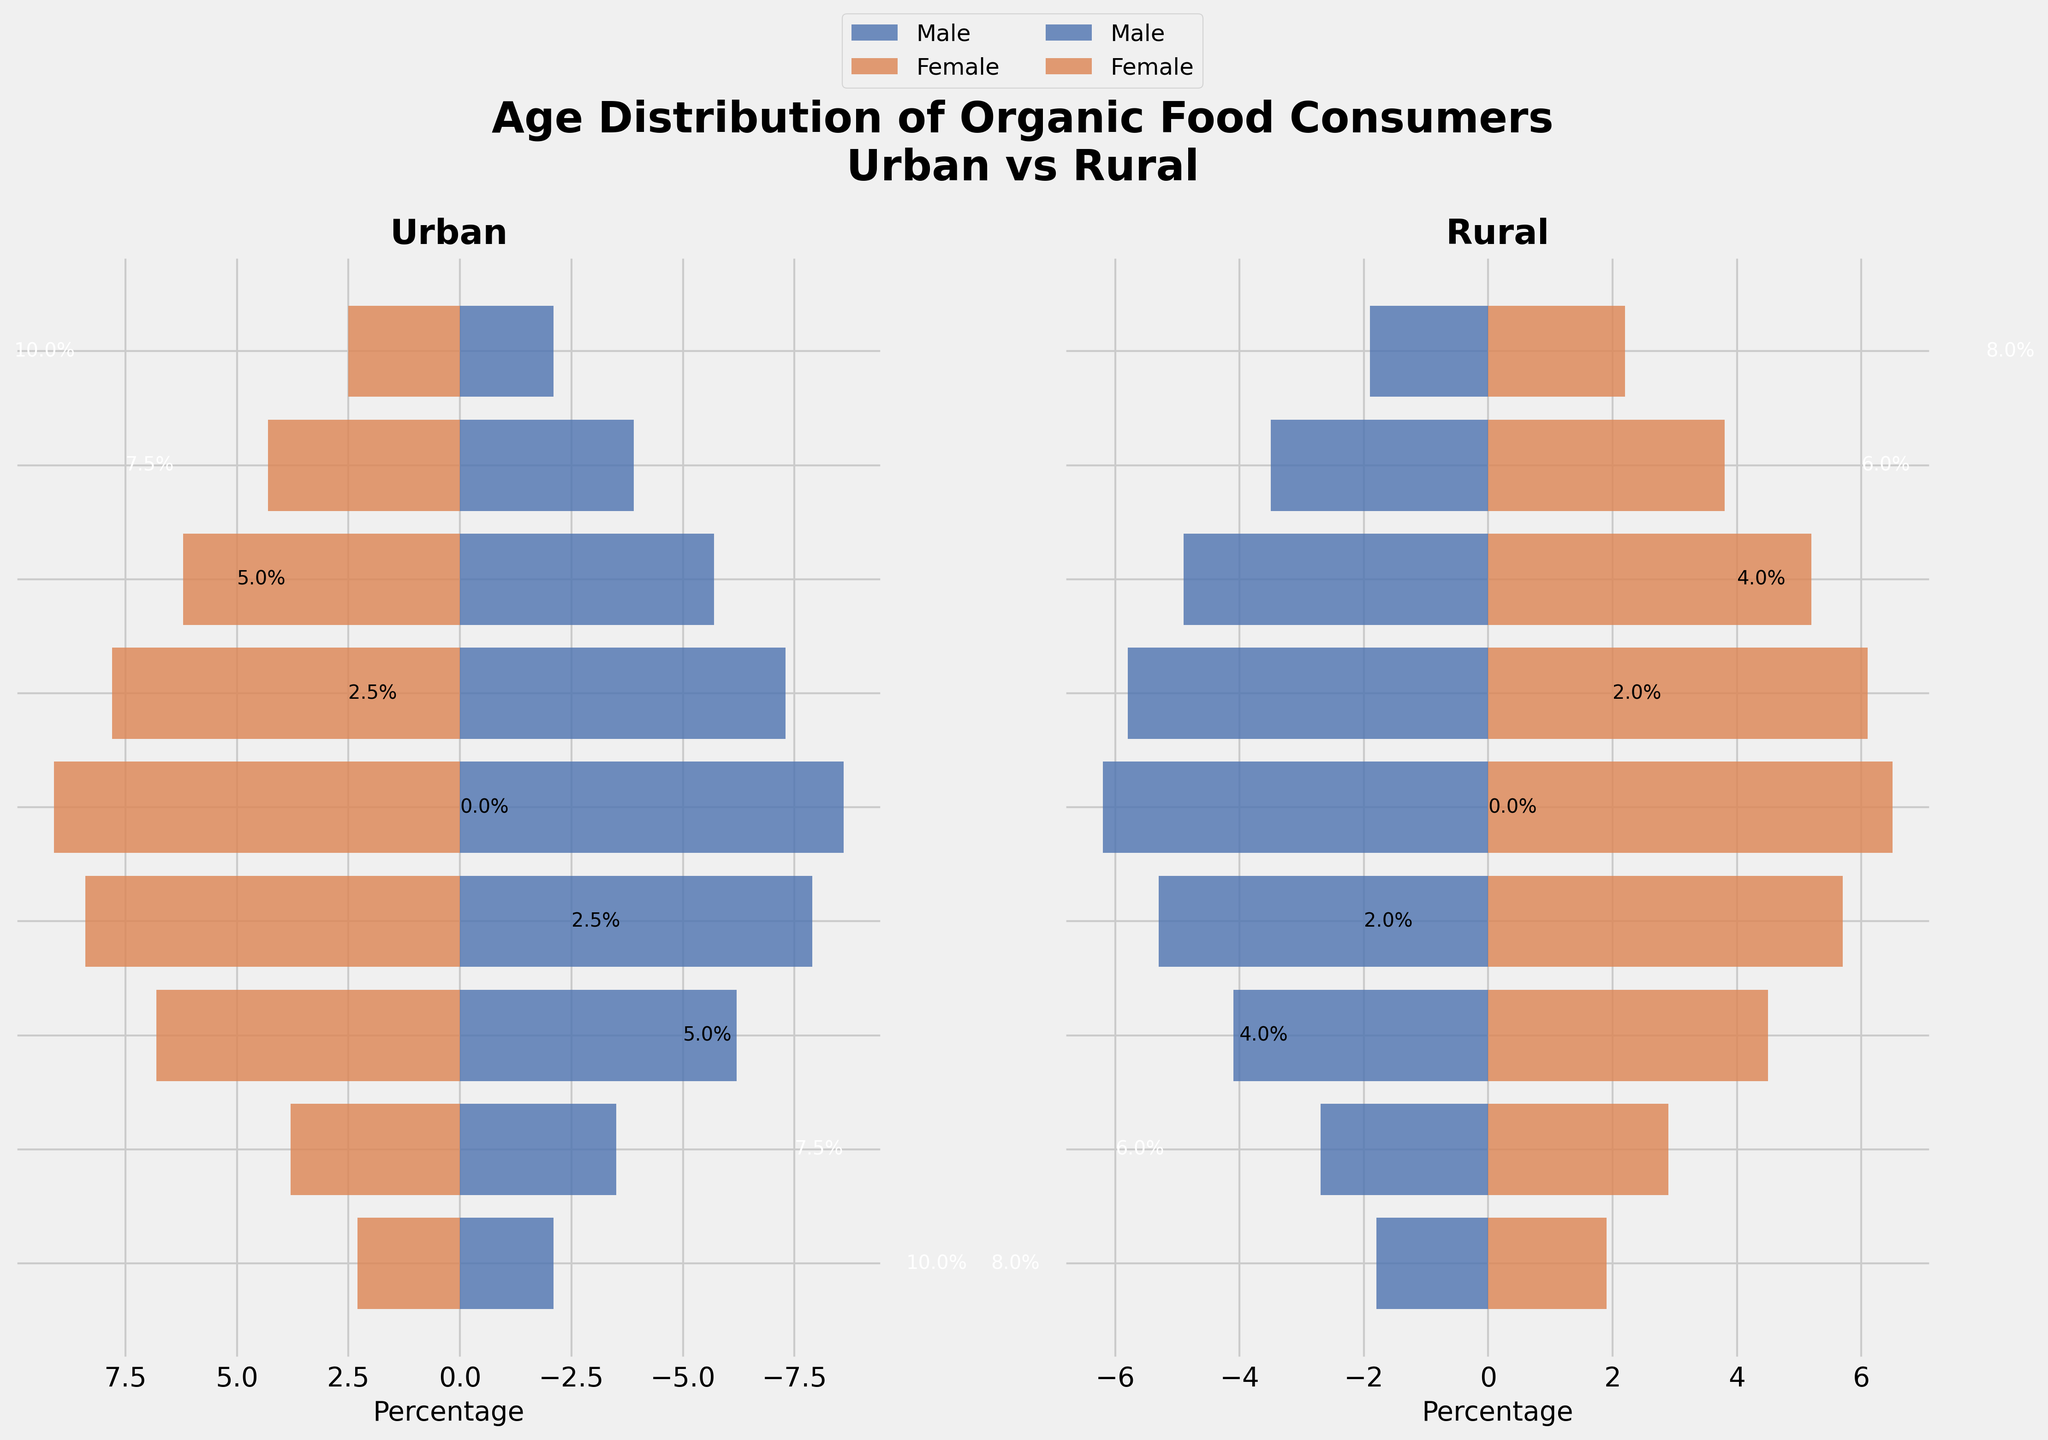What's the title of the figure? The title of the figure is displayed prominently at the top in a large font. It reads "Age Distribution of Organic Food Consumers\nUrban vs Rural."
Answer: Age Distribution of Organic Food Consumers\nUrban vs Rural Which age group has the largest percentage of urban female consumers? By examining the urban section of the figure, for each age group, observe the bar lengths for females. The age group 40-49 has the longest bar indicating the highest percentage of urban female consumers.
Answer: 40-49 Is the percentage of rural male consumers in the age group 30-39 greater than that in the age group 20-29? Compare the length of the rural male bar in the age group 30-39 with that in the age group 20-29. The bar for 30-39 is longer, indicating a higher percentage.
Answer: Yes What's the difference between urban female and rural female consumers in the 60-69 age group? Identify the lengths of the female bars for the urban and rural areas in the 60-69 age group. Subtract the rural percentage (5.2%) from the urban percentage (6.2%). The difference is 1.0%.
Answer: 1.0% Which age group has the smallest percentage of consumers across all categories? Observe the figure, focusing on the smallest bar for both males and females in both urban and rural sections. The 0-9 age group has the smallest bars indicating the lowest percentages overall.
Answer: 0-9 How do the percentages of consumers aged 50-59 compare between urban and rural areas for males? Compare the lengths of the bars for males in the 50-59 age group between the urban and rural sections. The urban bar (7.3%) is longer than the rural bar (5.8%), meaning urban has a higher percentage.
Answer: Urban is higher Identify the age group where the percentage difference between urban male and urban female consumers is greatest. For each age group, calculate the absolute difference between the lengths of the urban male and female bars. The age group 40-49 has the largest difference (0.5%).
Answer: 40-49 What is the total percentage of consumers in the urban area for the age group 20-29? Sum the percentages of both urban male (6.2%) and urban female (6.8%) consumers in the 20-29 age group. The total percentage is 13.0%.
Answer: 13.0% Which gender has a higher percentage of rural consumers in the age group 70-79? Compare the lengths of the rural male and female bars in the age group 70-79. The rural female bar (3.8%) is slightly longer than the male bar (3.5%), indicating a higher percentage of females.
Answer: Female Between urban and rural areas, which one has a higher percentage of male consumers in the 40-49 age group? Compare the length of the male bars for the 40-49 age group between urban (8.6%) and rural (6.2%). Urban has a higher percentage.
Answer: Urban 